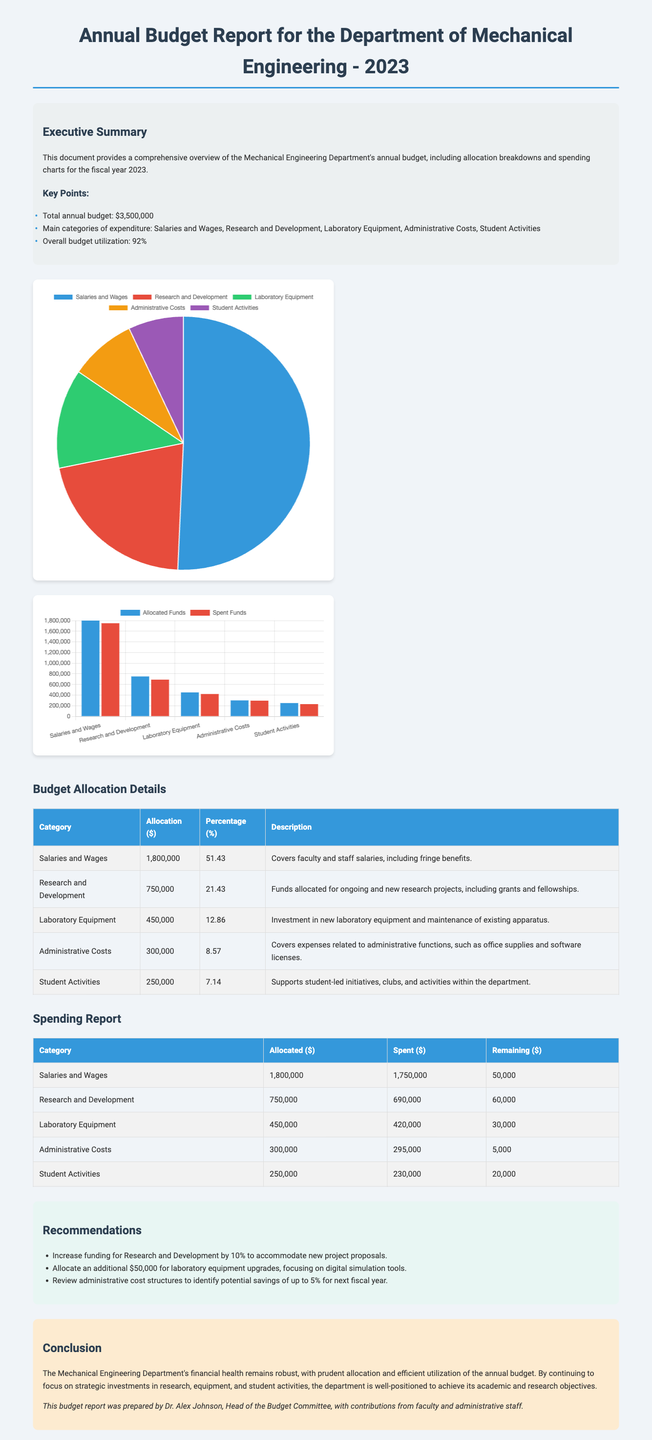What is the total annual budget? The total annual budget is stated in the executive summary section of the document.
Answer: $3,500,000 What percentage of the budget is allocated to Salaries and Wages? The document contains a detailed breakdown of budget allocations, with specific percentages for each category.
Answer: 51.43% How much was spent on Research and Development? The spending report table provides details on the amount spent in each category.
Answer: $690,000 What is the remaining balance for Laboratory Equipment? The spending report includes columns for allocated, spent, and remaining amounts for each budget category.
Answer: $30,000 Which category has the highest allocation? The budget allocation details indicate which category receives the largest share of the budget.
Answer: Salaries and Wages What is one recommendation made in the report? The recommendations section lists proposed actions based on budget assessment.
Answer: Increase funding for Research and Development by 10% What is the overall budget utilization percentage? The executive summary summarizes the department's performance in utilizing the budget.
Answer: 92% Who prepared the budget report? The conclusion section mentions the individual who prepared the report.
Answer: Dr. Alex Johnson How much was allocated for Student Activities? The allocation details table specifies the funds designated for each category.
Answer: $250,000 What type of chart is used to represent the budget allocation breakdown? The document includes specific mentions of different types of charts used for data visualization.
Answer: Pie Chart 